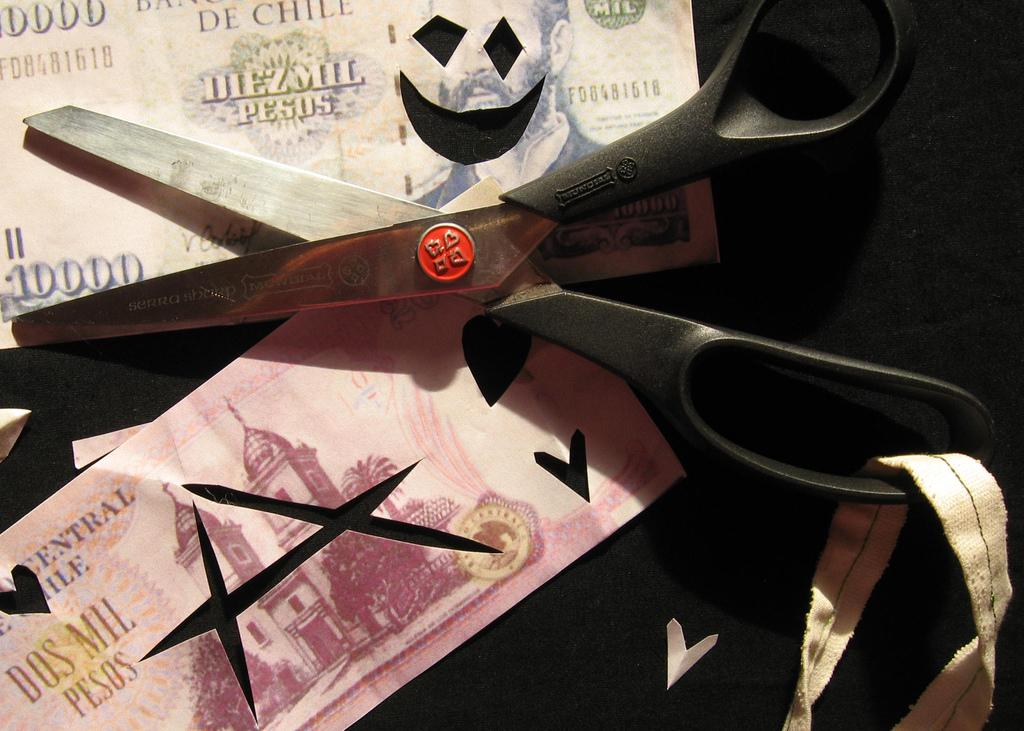What type of financial items are present in the image? There are currency notes in the image. What type of cutting tool is visible in the image? There are scissors in the image. What type of material is present in the image? There is a cloth in the image. What is the color of the background in the image? The background of the image is black. How many women are holding rifles in the image? There are no women or rifles present in the image. Where is the toothbrush located in the image? There is no toothbrush present in the image. 